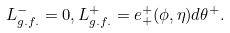<formula> <loc_0><loc_0><loc_500><loc_500>L _ { g . f . } ^ { - } = 0 , L _ { g . f . } ^ { + } = e _ { + } ^ { + } ( \phi , \eta ) d \theta ^ { + } .</formula> 